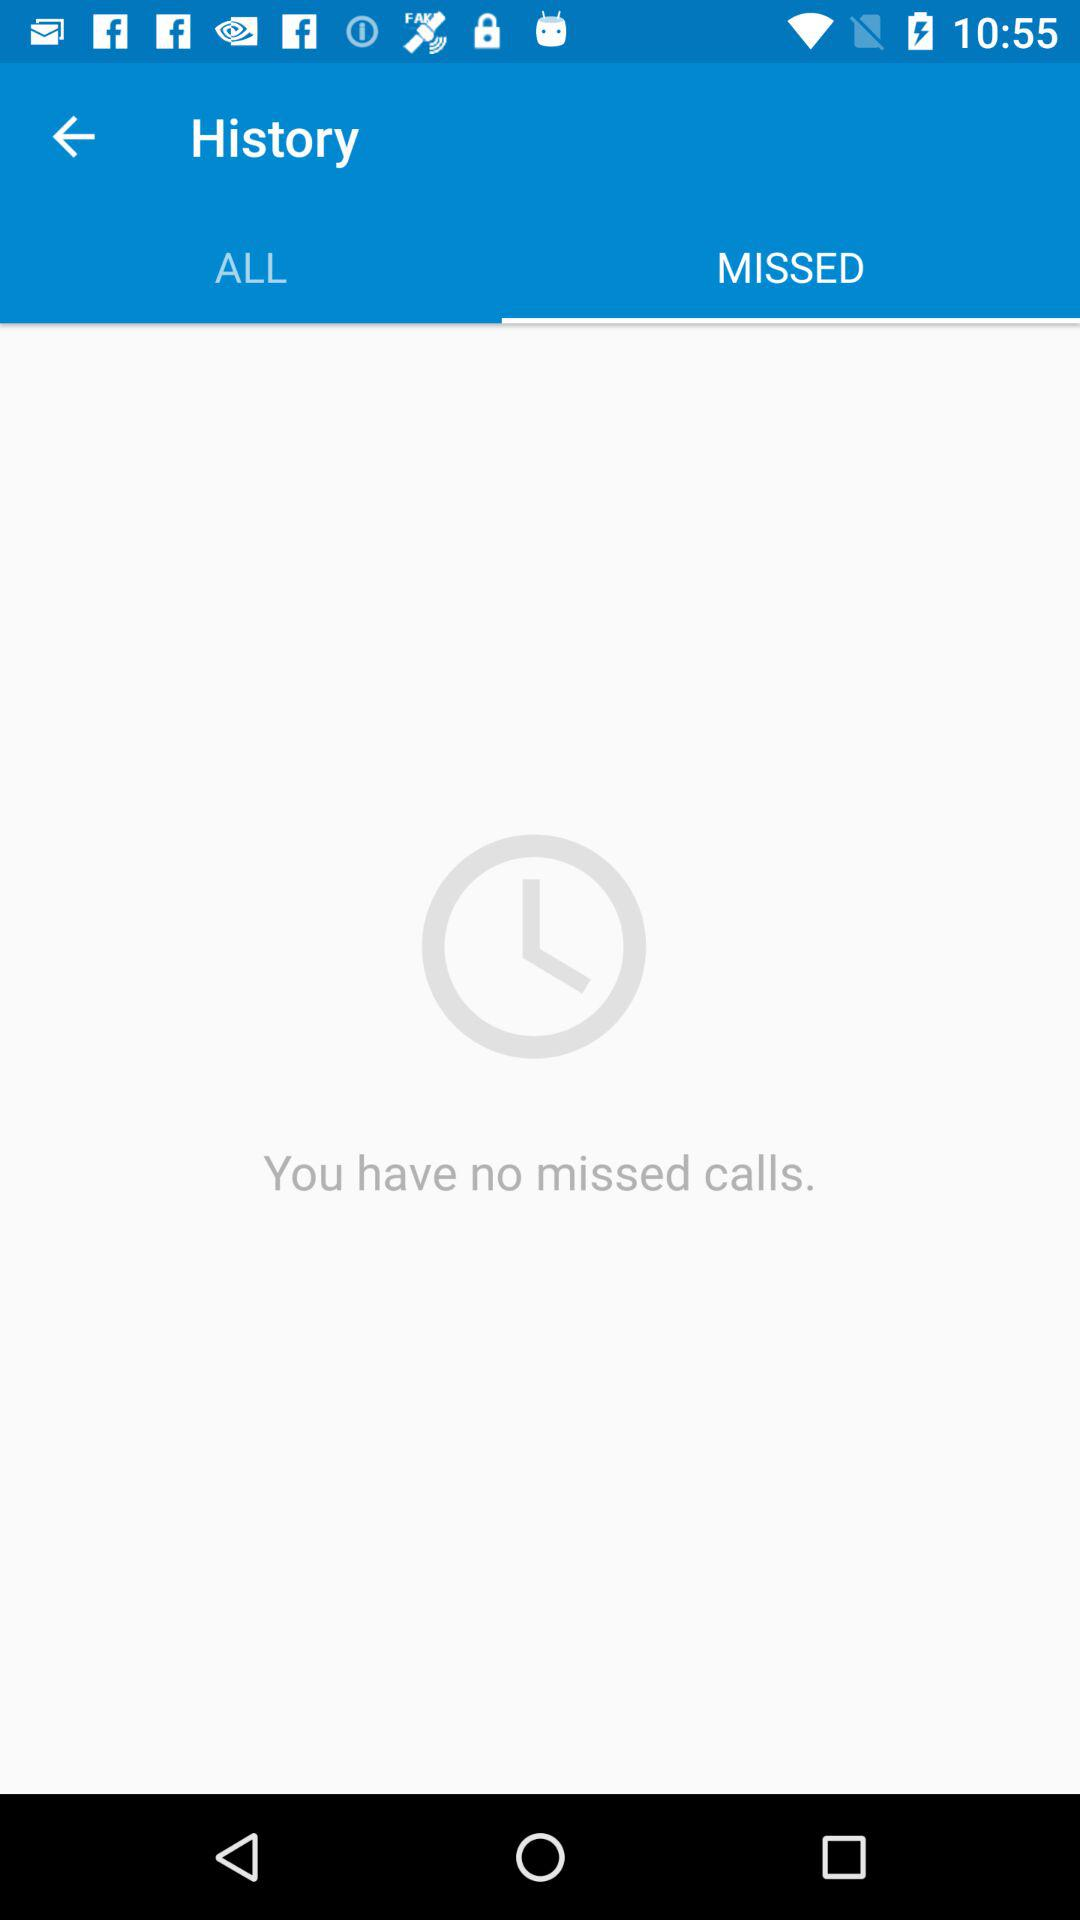How many calls have I missed?
Answer the question using a single word or phrase. 0 